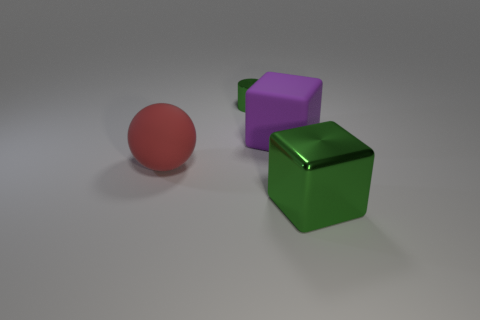There is a matte object that is right of the green metallic cylinder; is it the same size as the big red thing? The matte object to the right of the green metallic cube appears visually smaller than the big red sphere when comparing their sizes. However, without exact measurements, it's difficult to determine precise scale. 